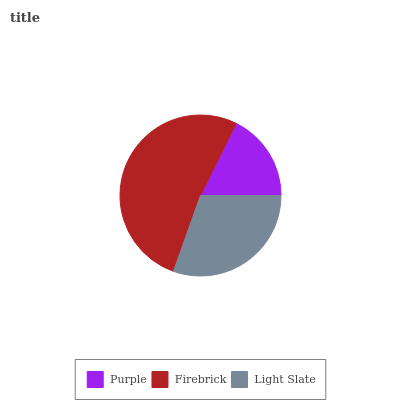Is Purple the minimum?
Answer yes or no. Yes. Is Firebrick the maximum?
Answer yes or no. Yes. Is Light Slate the minimum?
Answer yes or no. No. Is Light Slate the maximum?
Answer yes or no. No. Is Firebrick greater than Light Slate?
Answer yes or no. Yes. Is Light Slate less than Firebrick?
Answer yes or no. Yes. Is Light Slate greater than Firebrick?
Answer yes or no. No. Is Firebrick less than Light Slate?
Answer yes or no. No. Is Light Slate the high median?
Answer yes or no. Yes. Is Light Slate the low median?
Answer yes or no. Yes. Is Firebrick the high median?
Answer yes or no. No. Is Purple the low median?
Answer yes or no. No. 